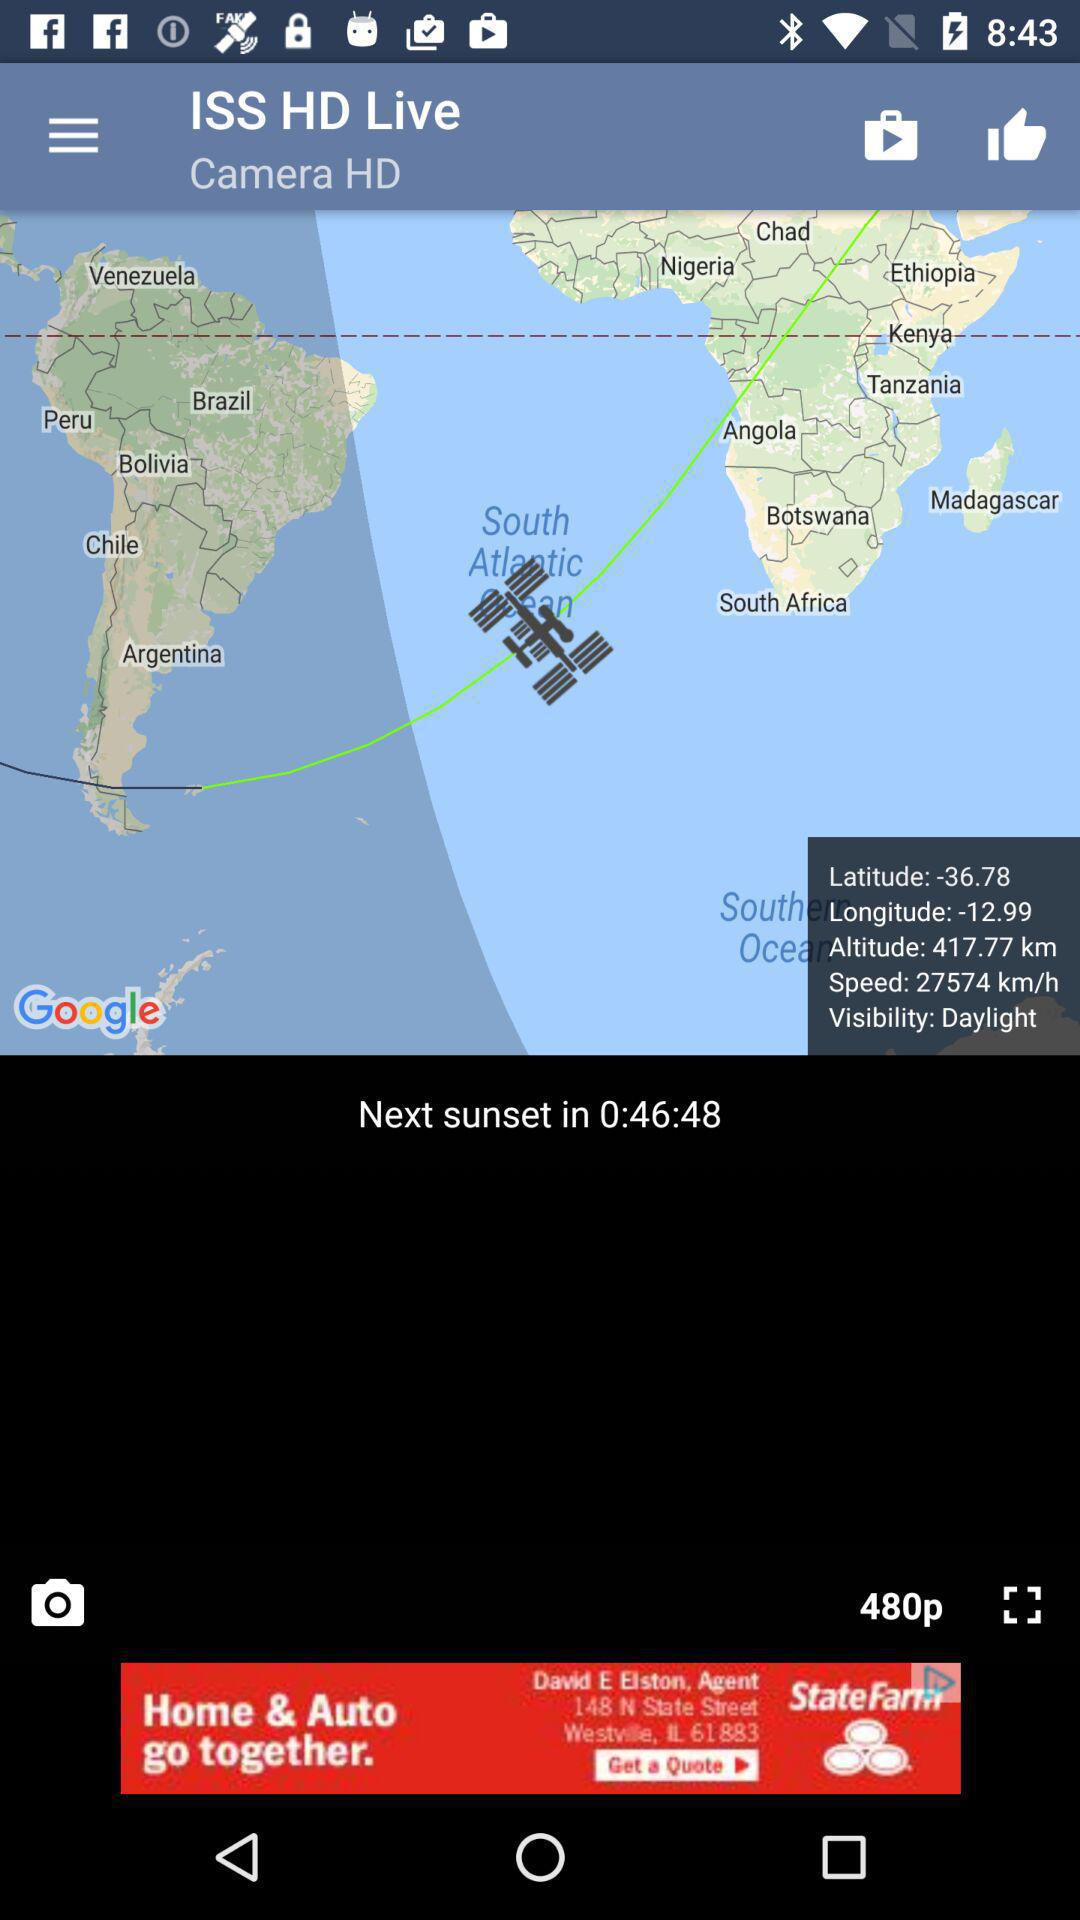What's the longitude and latitude? Longitude and latitude are -12.99 and -36.78. 